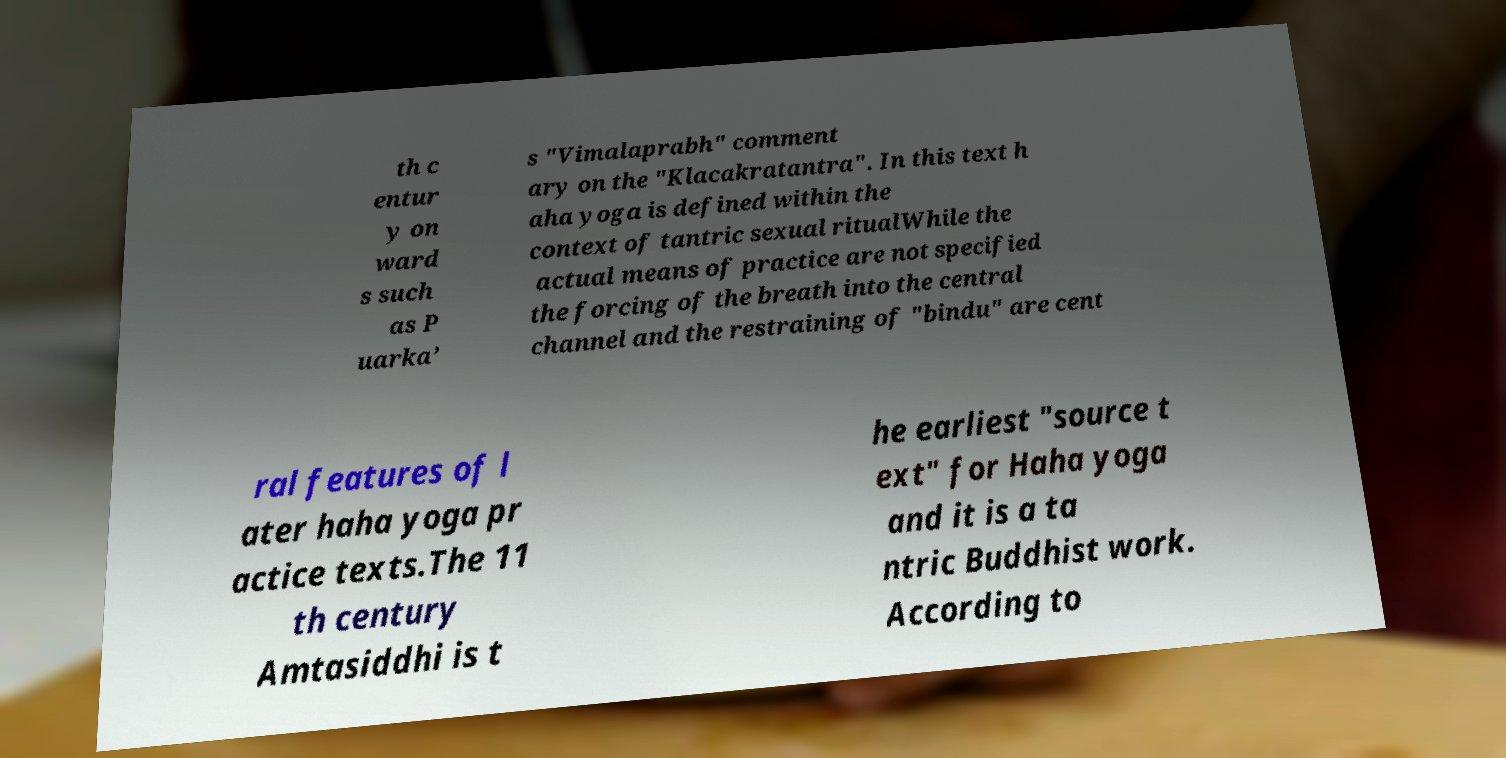Please read and relay the text visible in this image. What does it say? th c entur y on ward s such as P uarka’ s "Vimalaprabh" comment ary on the "Klacakratantra". In this text h aha yoga is defined within the context of tantric sexual ritualWhile the actual means of practice are not specified the forcing of the breath into the central channel and the restraining of "bindu" are cent ral features of l ater haha yoga pr actice texts.The 11 th century Amtasiddhi is t he earliest "source t ext" for Haha yoga and it is a ta ntric Buddhist work. According to 